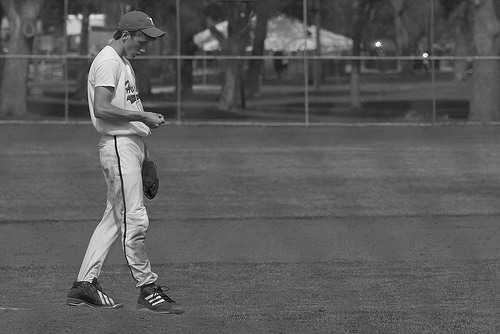Describe the objects in this image and their specific colors. I can see people in black, gray, darkgray, and lightgray tones and baseball glove in gray and black tones in this image. 